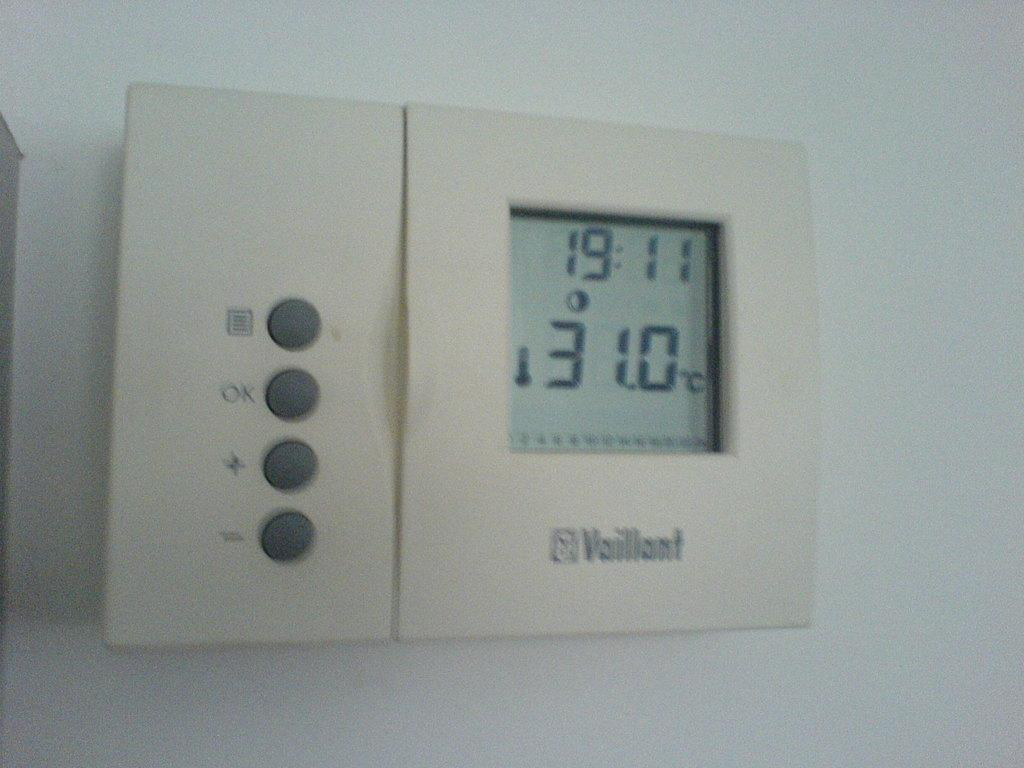<image>
Provide a brief description of the given image. A thermostat displays the temperature of 31.0 degrees C. 